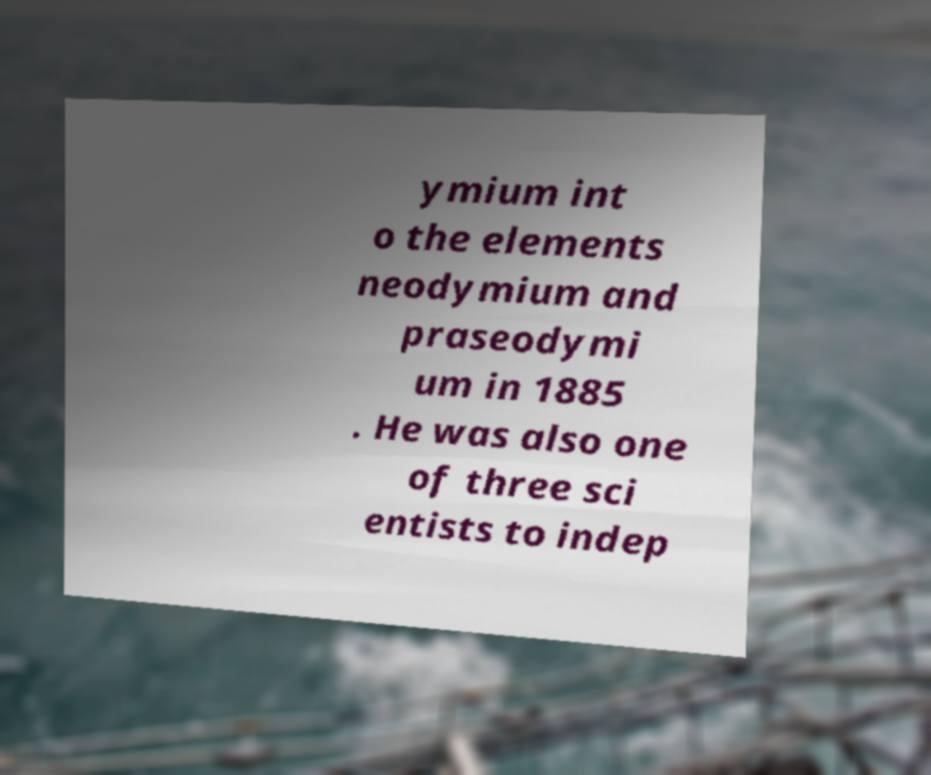Please identify and transcribe the text found in this image. ymium int o the elements neodymium and praseodymi um in 1885 . He was also one of three sci entists to indep 